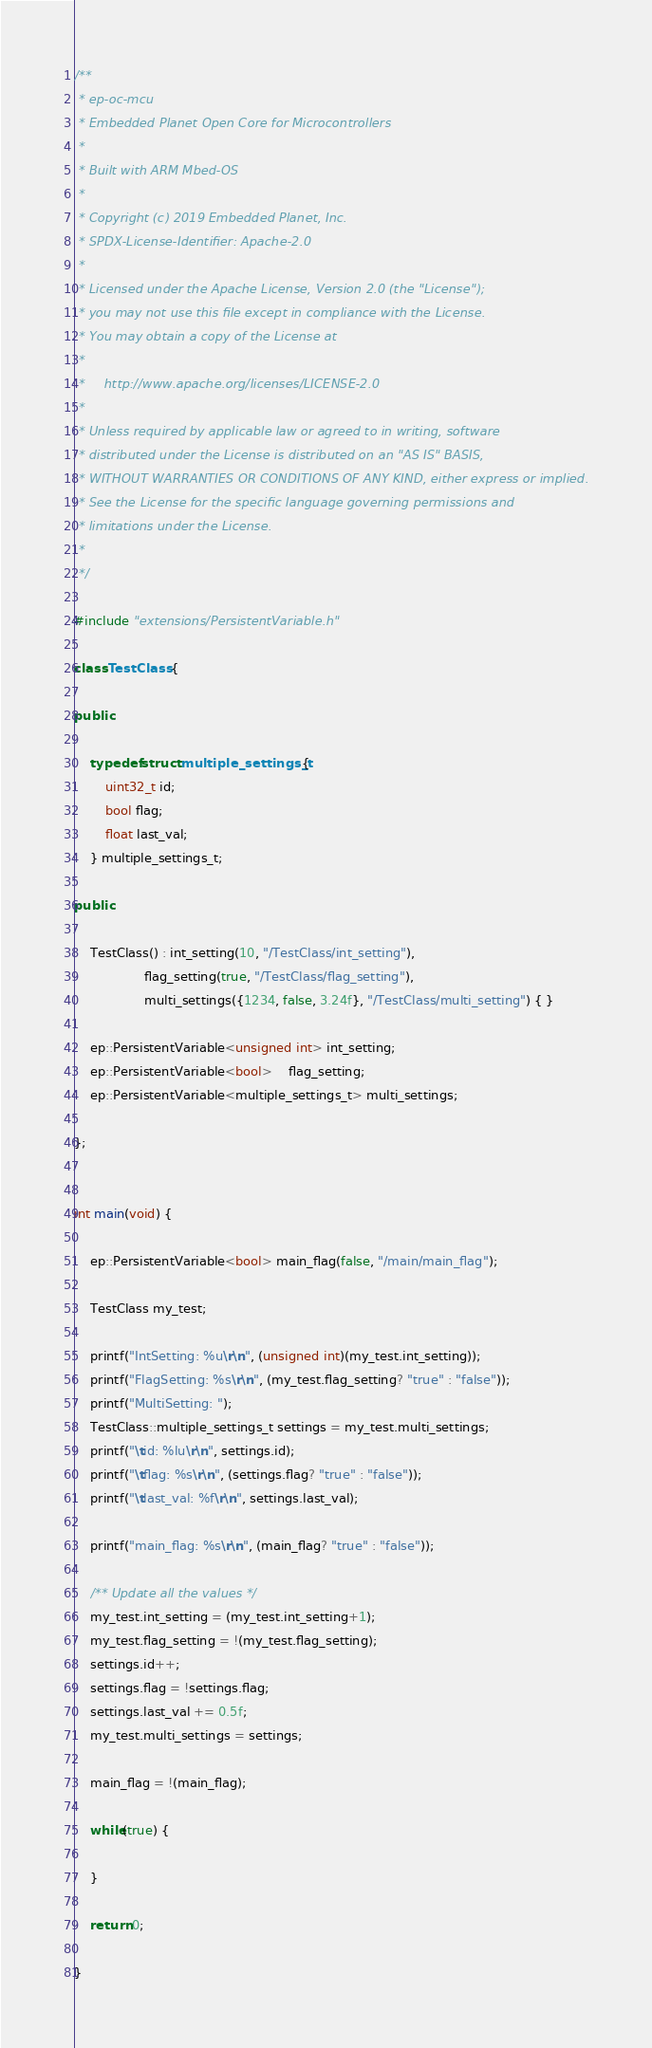<code> <loc_0><loc_0><loc_500><loc_500><_C++_>/**
 * ep-oc-mcu
 * Embedded Planet Open Core for Microcontrollers
 *
 * Built with ARM Mbed-OS
 *
 * Copyright (c) 2019 Embedded Planet, Inc.
 * SPDX-License-Identifier: Apache-2.0
 *
 * Licensed under the Apache License, Version 2.0 (the "License");
 * you may not use this file except in compliance with the License.
 * You may obtain a copy of the License at
 *
 *     http://www.apache.org/licenses/LICENSE-2.0
 *
 * Unless required by applicable law or agreed to in writing, software
 * distributed under the License is distributed on an "AS IS" BASIS,
 * WITHOUT WARRANTIES OR CONDITIONS OF ANY KIND, either express or implied.
 * See the License for the specific language governing permissions and
 * limitations under the License.
 *
 */

#include "extensions/PersistentVariable.h"

class TestClass {

public:

	typedef struct multiple_settings_t {
		uint32_t id;
		bool flag;
		float last_val;
	} multiple_settings_t;

public:

	TestClass() : int_setting(10, "/TestClass/int_setting"),
				  flag_setting(true, "/TestClass/flag_setting"),
				  multi_settings({1234, false, 3.24f}, "/TestClass/multi_setting") { }

	ep::PersistentVariable<unsigned int> int_setting;
	ep::PersistentVariable<bool>	flag_setting;
	ep::PersistentVariable<multiple_settings_t> multi_settings;

};


int main(void) {

	ep::PersistentVariable<bool> main_flag(false, "/main/main_flag");

	TestClass my_test;

	printf("IntSetting: %u\r\n", (unsigned int)(my_test.int_setting));
	printf("FlagSetting: %s\r\n", (my_test.flag_setting? "true" : "false"));
	printf("MultiSetting: ");
	TestClass::multiple_settings_t settings = my_test.multi_settings;
	printf("\tid: %lu\r\n", settings.id);
	printf("\tflag: %s\r\n", (settings.flag? "true" : "false"));
	printf("\tlast_val: %f\r\n", settings.last_val);

	printf("main_flag: %s\r\n", (main_flag? "true" : "false"));

	/** Update all the values */
	my_test.int_setting = (my_test.int_setting+1);
	my_test.flag_setting = !(my_test.flag_setting);
	settings.id++;
	settings.flag = !settings.flag;
	settings.last_val += 0.5f;
	my_test.multi_settings = settings;

	main_flag = !(main_flag);

	while(true) {

	}

	return 0;

}
</code> 